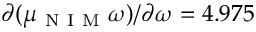<formula> <loc_0><loc_0><loc_500><loc_500>\partial ( \mu _ { N I M } \omega ) / \partial \omega = 4 . 9 7 5</formula> 